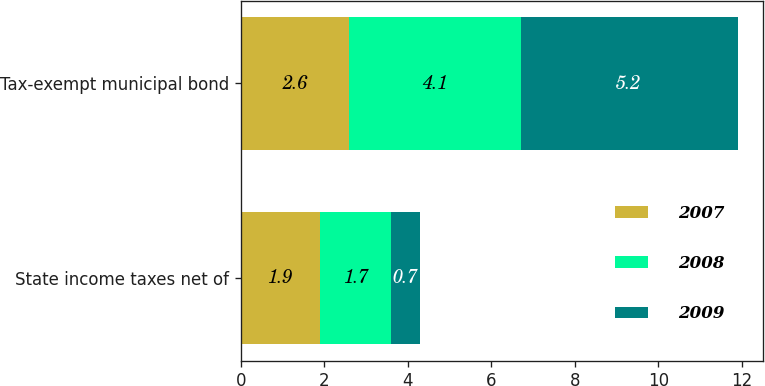<chart> <loc_0><loc_0><loc_500><loc_500><stacked_bar_chart><ecel><fcel>State income taxes net of<fcel>Tax-exempt municipal bond<nl><fcel>2007<fcel>1.9<fcel>2.6<nl><fcel>2008<fcel>1.7<fcel>4.1<nl><fcel>2009<fcel>0.7<fcel>5.2<nl></chart> 